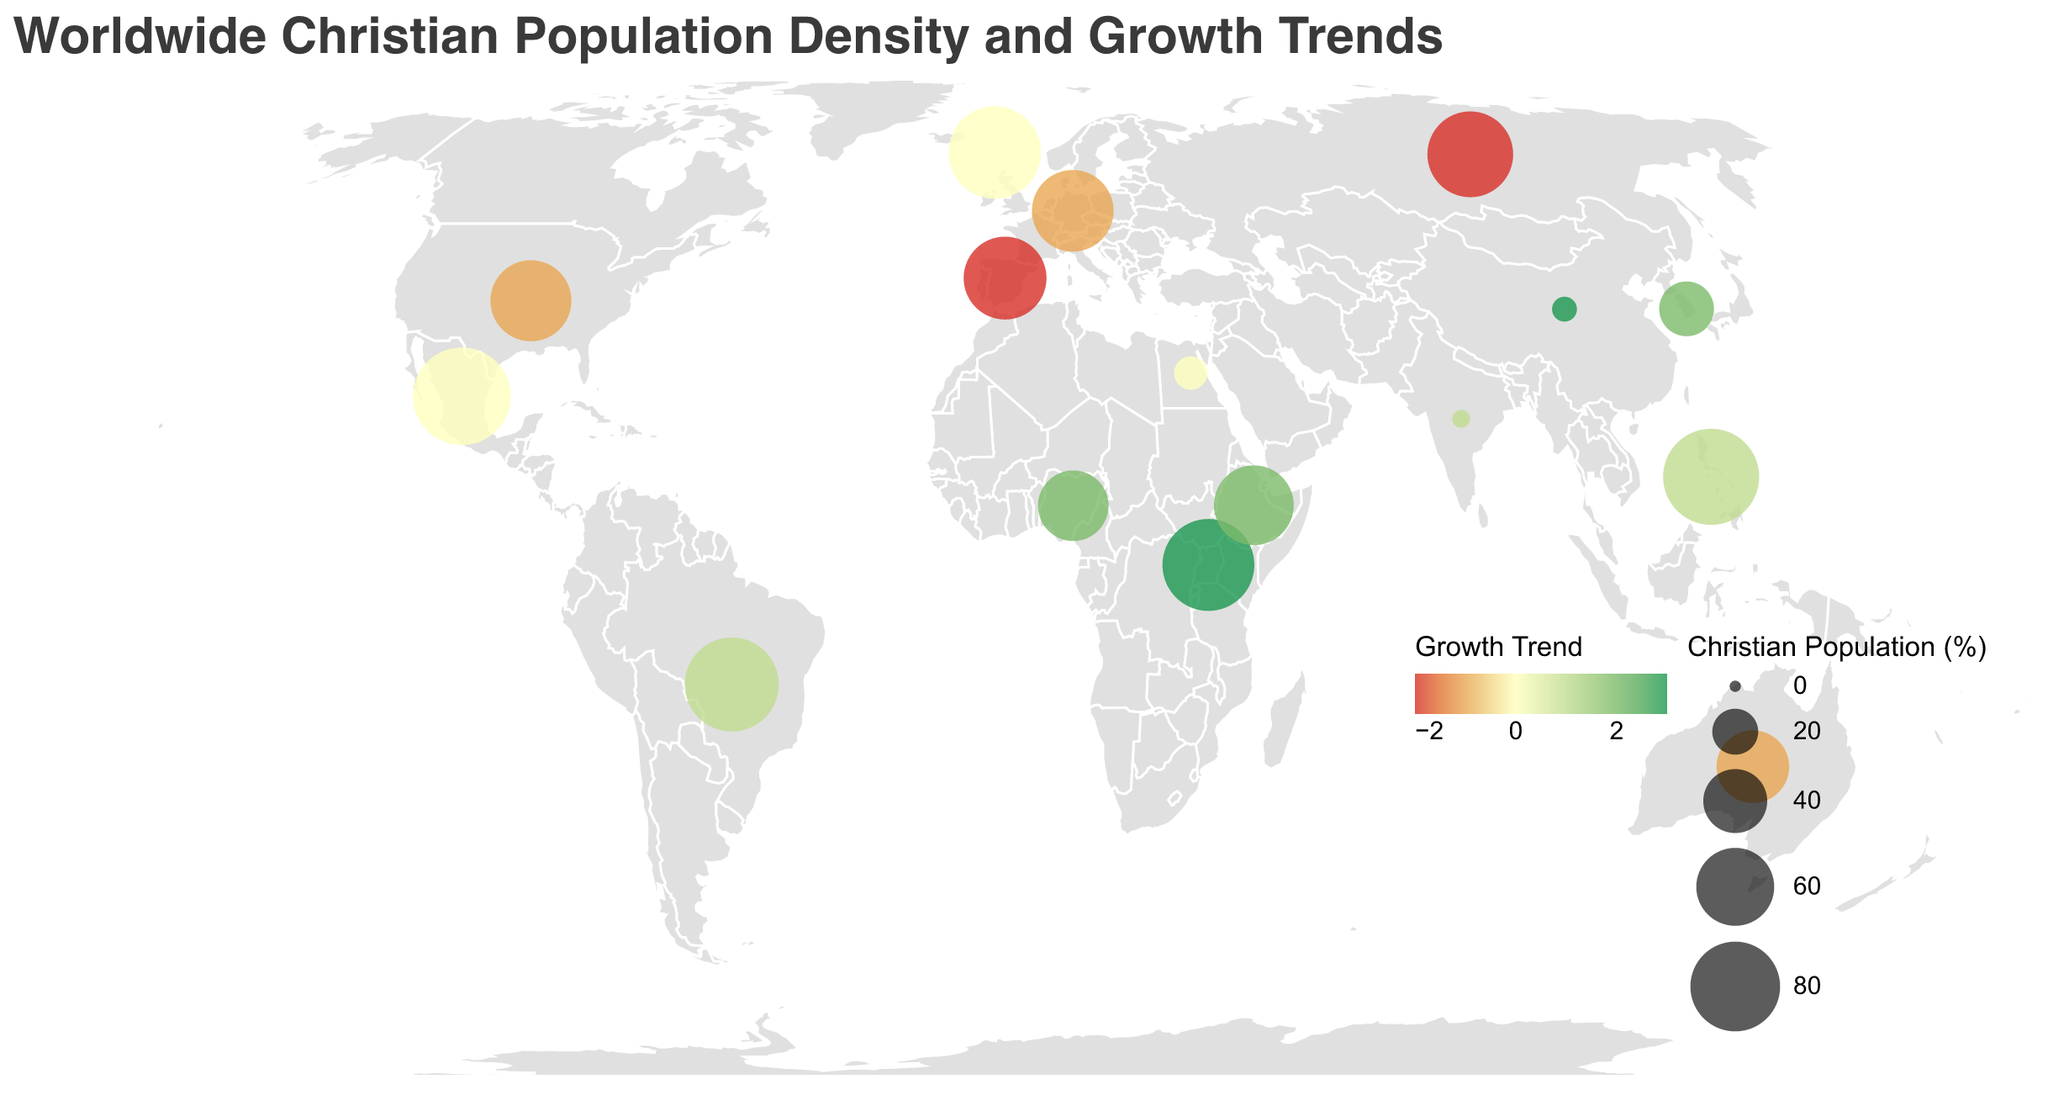Which country has the highest percentage of Christians? Look at the size of the circles and the tooltip values; the largest circle corresponds to Mexico with 95%.
Answer: Mexico Which three countries have the largest growth trend? Compare the color of the circles. The circles with the greenest color indicate the highest growth trend, which are China, Uganda, and Nigeria, each with growth trends of 3.
Answer: China, Uganda, and Nigeria What is the growth trend for the Faroe Islands? Check the tooltip for the Faroe Islands, which shows the growth trend as 0, indicated by a circle color closer to yellow.
Answer: 0 How does the Christian percentage in Nigeria compare to South Korea? Compare the sizes of the circles for Nigeria and South Korea. Nigeria has 49% while South Korea has 29%.
Answer: Nigeria has a higher percentage than South Korea Which countries show a decline in the Christian population? Identify the countries with red-toned circles, which indicate a negative growth trend. These countries are Russia, Germany, Spain, and Australia.
Answer: Russia, Germany, Spain, and Australia What is the percentage of Christians in the Philippines? Look at the tooltip for the Philippines, showing a Christian percentage of 92%.
Answer: 92% Which country has the same growth trend as Egypt? Egypt has a growth trend of 0, as shown by a yellow circle. The Faroe Islands and Mexico also have circles close to yellow, indicating a growth trend of 0.
Answer: Faroe Islands and Mexico What is the average Christian percentage of the countries with a positive growth trend? Identify countries with green or slightly green circles, then calculate their average Christian percentage: Brazil (88), Nigeria (49), China (5), Philippines (92), South Korea (29), Uganda (84), India (2), and Ethiopia (63). The sum is 412, divided by 8 gives 51.5%.
Answer: 51.5% Which countries have higher than 80% Christian population? Look at the largest circles and read their tooltip values to identify countries with over 80% Christians. These are Brazil (88%), Philippines (92%), Uganda (84%), Mexico (95%), and the Faroe Islands (85%).
Answer: Brazil, Philippines, Uganda, Mexico, and the Faroe Islands Which countries have a Christian population percentage between 60% and 70%? Identify circles with medium size and their tooltip values to find countries within the given range: United States (65%), Germany (66%), and Spain (68%).
Answer: United States, Germany, and Spain 